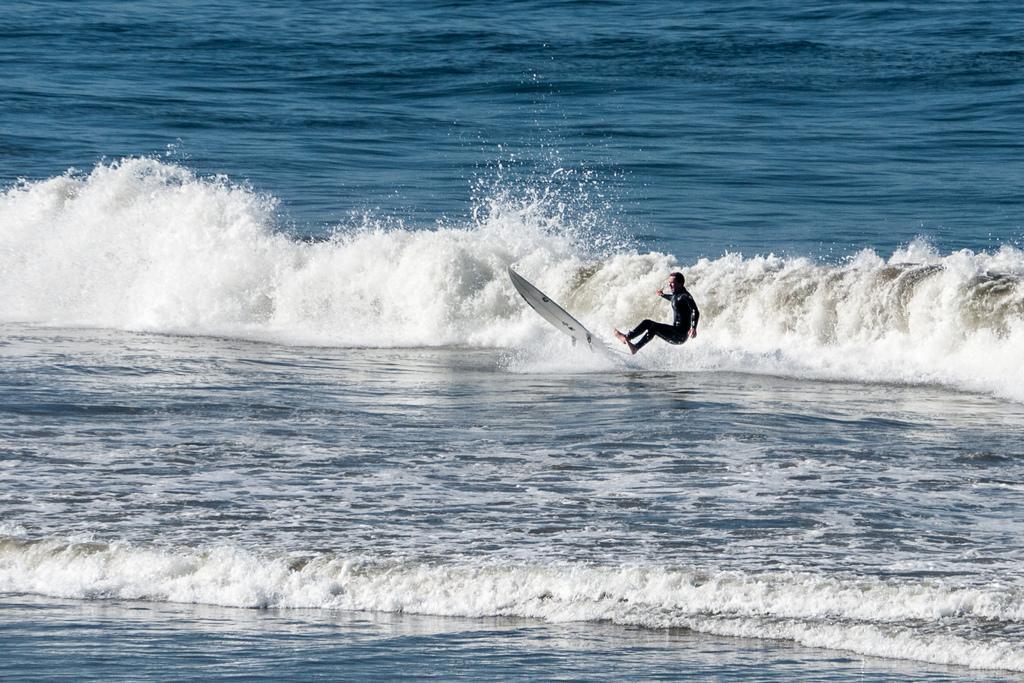In one or two sentences, can you explain what this image depicts? In this picture I can see a man is surfing on the water. The man is wearing black color clothes. 